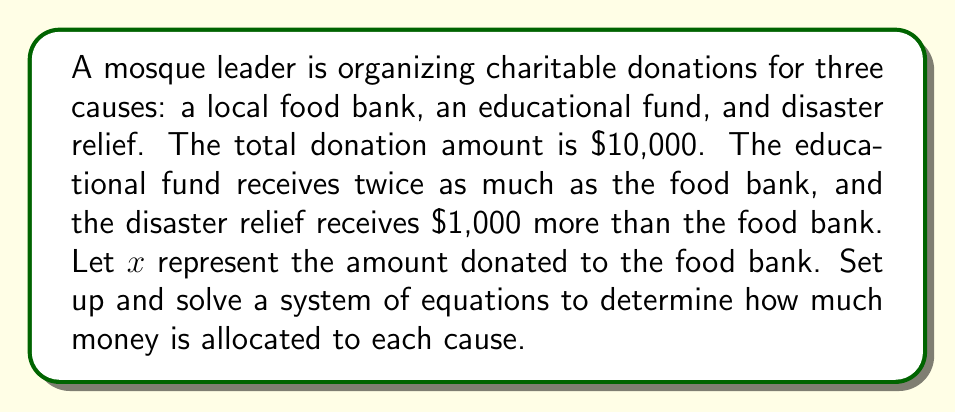What is the answer to this math problem? Let's set up our system of equations based on the given information:

1) Let $x$ = amount donated to the food bank
2) Educational fund receives twice as much as the food bank: $2x$
3) Disaster relief receives $1,000 more than the food bank: $x + 1000$
4) The total donation is $10,000

Now, we can create our equation:

$$x + 2x + (x + 1000) = 10000$$

Simplifying:
$$4x + 1000 = 10000$$

Subtracting 1000 from both sides:
$$4x = 9000$$

Dividing both sides by 4:
$$x = 2250$$

Now that we know $x$, we can calculate the other amounts:

Food bank: $x = 2250$
Educational fund: $2x = 2(2250) = 4500$
Disaster relief: $x + 1000 = 2250 + 1000 = 3250$

Let's verify:
$$2250 + 4500 + 3250 = 10000$$

The equation balances, confirming our solution.
Answer: Food bank: $2250, Educational fund: $4500, Disaster relief: $3250 